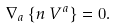<formula> <loc_0><loc_0><loc_500><loc_500>\nabla _ { a } \left \{ n \, V ^ { a } \right \} = 0 .</formula> 